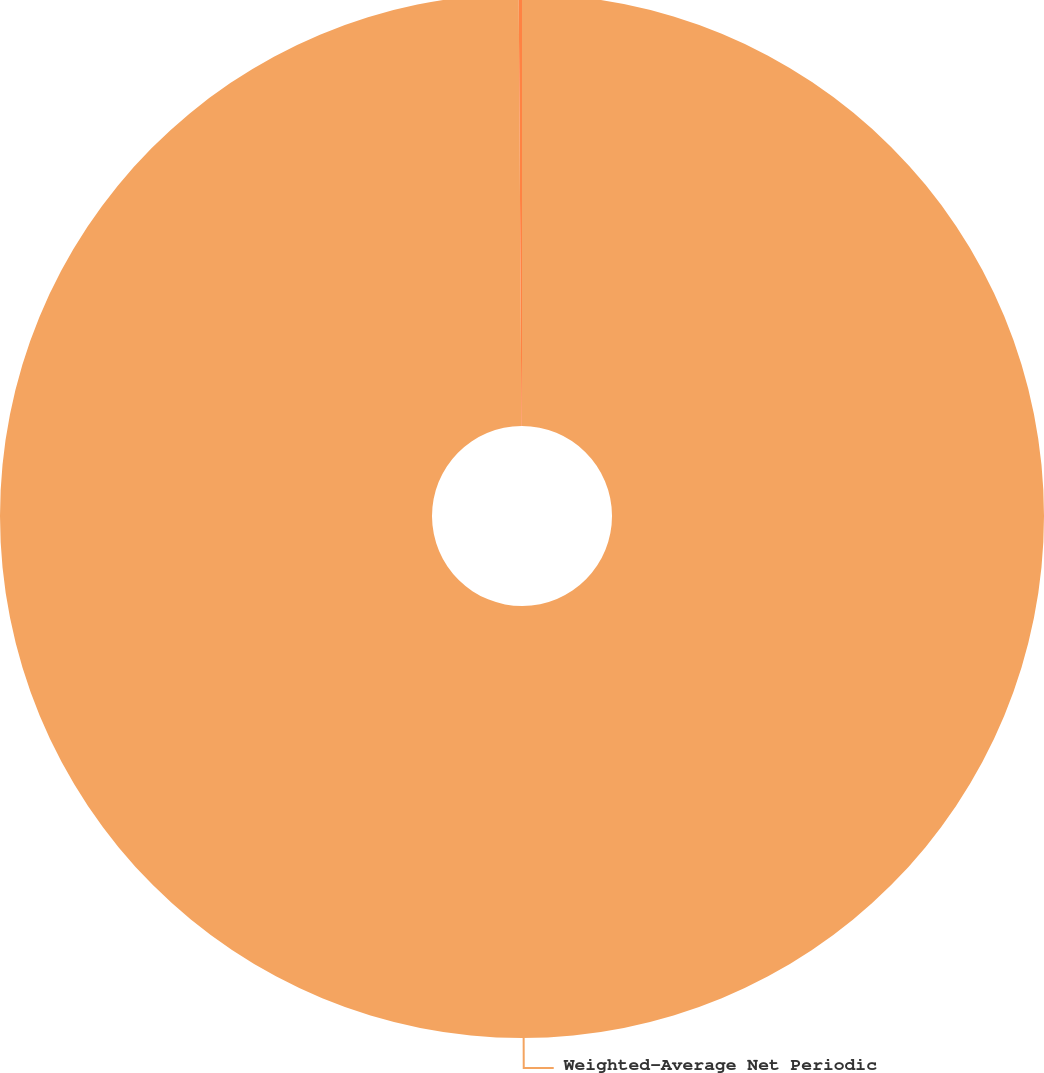Convert chart. <chart><loc_0><loc_0><loc_500><loc_500><pie_chart><fcel>Weighted-Average Net Periodic<fcel>Discount rate<nl><fcel>99.9%<fcel>0.1%<nl></chart> 